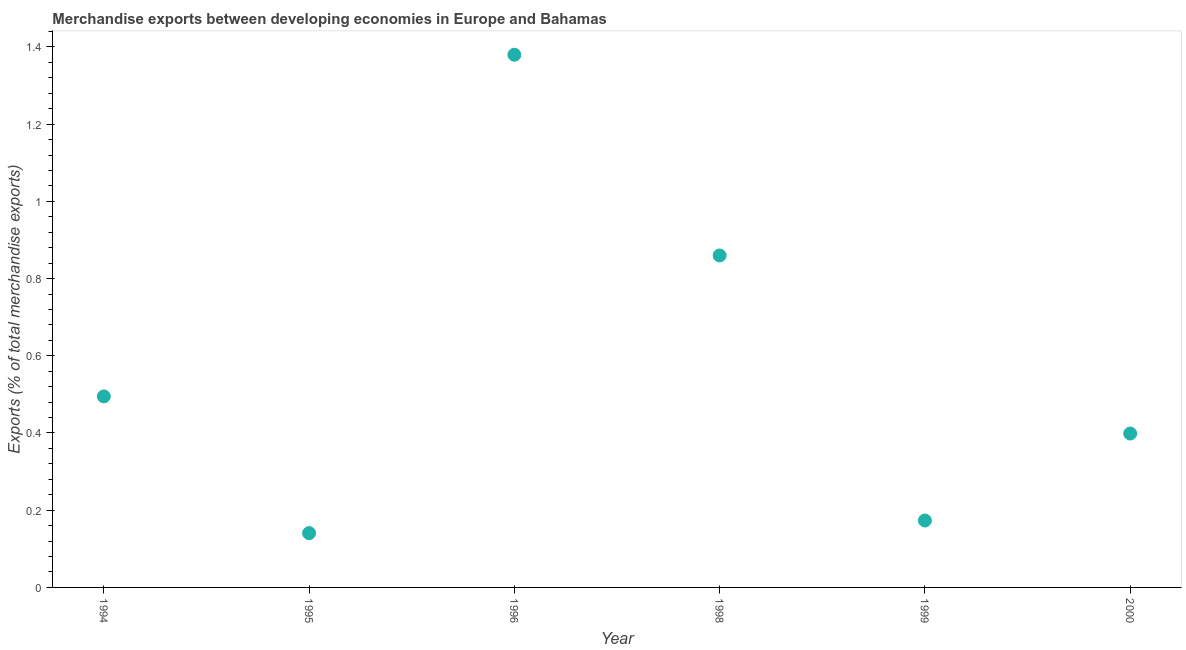What is the merchandise exports in 2000?
Offer a very short reply. 0.4. Across all years, what is the maximum merchandise exports?
Provide a succinct answer. 1.38. Across all years, what is the minimum merchandise exports?
Your response must be concise. 0.14. In which year was the merchandise exports maximum?
Ensure brevity in your answer.  1996. In which year was the merchandise exports minimum?
Your answer should be compact. 1995. What is the sum of the merchandise exports?
Your answer should be compact. 3.45. What is the difference between the merchandise exports in 1995 and 1998?
Keep it short and to the point. -0.72. What is the average merchandise exports per year?
Offer a very short reply. 0.57. What is the median merchandise exports?
Provide a short and direct response. 0.45. Do a majority of the years between 1996 and 2000 (inclusive) have merchandise exports greater than 1 %?
Provide a short and direct response. No. What is the ratio of the merchandise exports in 1995 to that in 1999?
Offer a very short reply. 0.81. Is the merchandise exports in 1998 less than that in 1999?
Offer a very short reply. No. Is the difference between the merchandise exports in 1995 and 2000 greater than the difference between any two years?
Your answer should be compact. No. What is the difference between the highest and the second highest merchandise exports?
Your answer should be very brief. 0.52. What is the difference between the highest and the lowest merchandise exports?
Offer a very short reply. 1.24. How many dotlines are there?
Ensure brevity in your answer.  1. Does the graph contain grids?
Provide a short and direct response. No. What is the title of the graph?
Your answer should be compact. Merchandise exports between developing economies in Europe and Bahamas. What is the label or title of the Y-axis?
Give a very brief answer. Exports (% of total merchandise exports). What is the Exports (% of total merchandise exports) in 1994?
Your answer should be very brief. 0.49. What is the Exports (% of total merchandise exports) in 1995?
Provide a short and direct response. 0.14. What is the Exports (% of total merchandise exports) in 1996?
Give a very brief answer. 1.38. What is the Exports (% of total merchandise exports) in 1998?
Offer a very short reply. 0.86. What is the Exports (% of total merchandise exports) in 1999?
Ensure brevity in your answer.  0.17. What is the Exports (% of total merchandise exports) in 2000?
Your response must be concise. 0.4. What is the difference between the Exports (% of total merchandise exports) in 1994 and 1995?
Your answer should be compact. 0.35. What is the difference between the Exports (% of total merchandise exports) in 1994 and 1996?
Provide a short and direct response. -0.88. What is the difference between the Exports (% of total merchandise exports) in 1994 and 1998?
Provide a succinct answer. -0.37. What is the difference between the Exports (% of total merchandise exports) in 1994 and 1999?
Provide a succinct answer. 0.32. What is the difference between the Exports (% of total merchandise exports) in 1994 and 2000?
Ensure brevity in your answer.  0.1. What is the difference between the Exports (% of total merchandise exports) in 1995 and 1996?
Provide a succinct answer. -1.24. What is the difference between the Exports (% of total merchandise exports) in 1995 and 1998?
Your answer should be very brief. -0.72. What is the difference between the Exports (% of total merchandise exports) in 1995 and 1999?
Your response must be concise. -0.03. What is the difference between the Exports (% of total merchandise exports) in 1995 and 2000?
Make the answer very short. -0.26. What is the difference between the Exports (% of total merchandise exports) in 1996 and 1998?
Ensure brevity in your answer.  0.52. What is the difference between the Exports (% of total merchandise exports) in 1996 and 1999?
Offer a very short reply. 1.21. What is the difference between the Exports (% of total merchandise exports) in 1996 and 2000?
Your answer should be compact. 0.98. What is the difference between the Exports (% of total merchandise exports) in 1998 and 1999?
Provide a succinct answer. 0.69. What is the difference between the Exports (% of total merchandise exports) in 1998 and 2000?
Give a very brief answer. 0.46. What is the difference between the Exports (% of total merchandise exports) in 1999 and 2000?
Your answer should be compact. -0.23. What is the ratio of the Exports (% of total merchandise exports) in 1994 to that in 1995?
Offer a very short reply. 3.52. What is the ratio of the Exports (% of total merchandise exports) in 1994 to that in 1996?
Ensure brevity in your answer.  0.36. What is the ratio of the Exports (% of total merchandise exports) in 1994 to that in 1998?
Your response must be concise. 0.57. What is the ratio of the Exports (% of total merchandise exports) in 1994 to that in 1999?
Offer a terse response. 2.85. What is the ratio of the Exports (% of total merchandise exports) in 1994 to that in 2000?
Offer a very short reply. 1.24. What is the ratio of the Exports (% of total merchandise exports) in 1995 to that in 1996?
Your response must be concise. 0.1. What is the ratio of the Exports (% of total merchandise exports) in 1995 to that in 1998?
Your response must be concise. 0.16. What is the ratio of the Exports (% of total merchandise exports) in 1995 to that in 1999?
Your answer should be compact. 0.81. What is the ratio of the Exports (% of total merchandise exports) in 1995 to that in 2000?
Give a very brief answer. 0.35. What is the ratio of the Exports (% of total merchandise exports) in 1996 to that in 1998?
Give a very brief answer. 1.6. What is the ratio of the Exports (% of total merchandise exports) in 1996 to that in 1999?
Your answer should be very brief. 7.96. What is the ratio of the Exports (% of total merchandise exports) in 1996 to that in 2000?
Your response must be concise. 3.46. What is the ratio of the Exports (% of total merchandise exports) in 1998 to that in 1999?
Your answer should be very brief. 4.96. What is the ratio of the Exports (% of total merchandise exports) in 1998 to that in 2000?
Offer a very short reply. 2.16. What is the ratio of the Exports (% of total merchandise exports) in 1999 to that in 2000?
Provide a short and direct response. 0.43. 